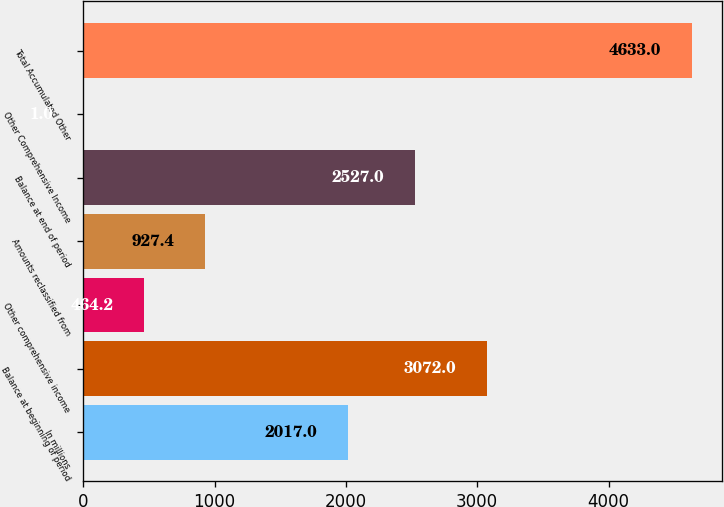Convert chart to OTSL. <chart><loc_0><loc_0><loc_500><loc_500><bar_chart><fcel>In millions<fcel>Balance at beginning of period<fcel>Other comprehensive income<fcel>Amounts reclassified from<fcel>Balance at end of period<fcel>Other Comprehensive Income<fcel>Total Accumulated Other<nl><fcel>2017<fcel>3072<fcel>464.2<fcel>927.4<fcel>2527<fcel>1<fcel>4633<nl></chart> 